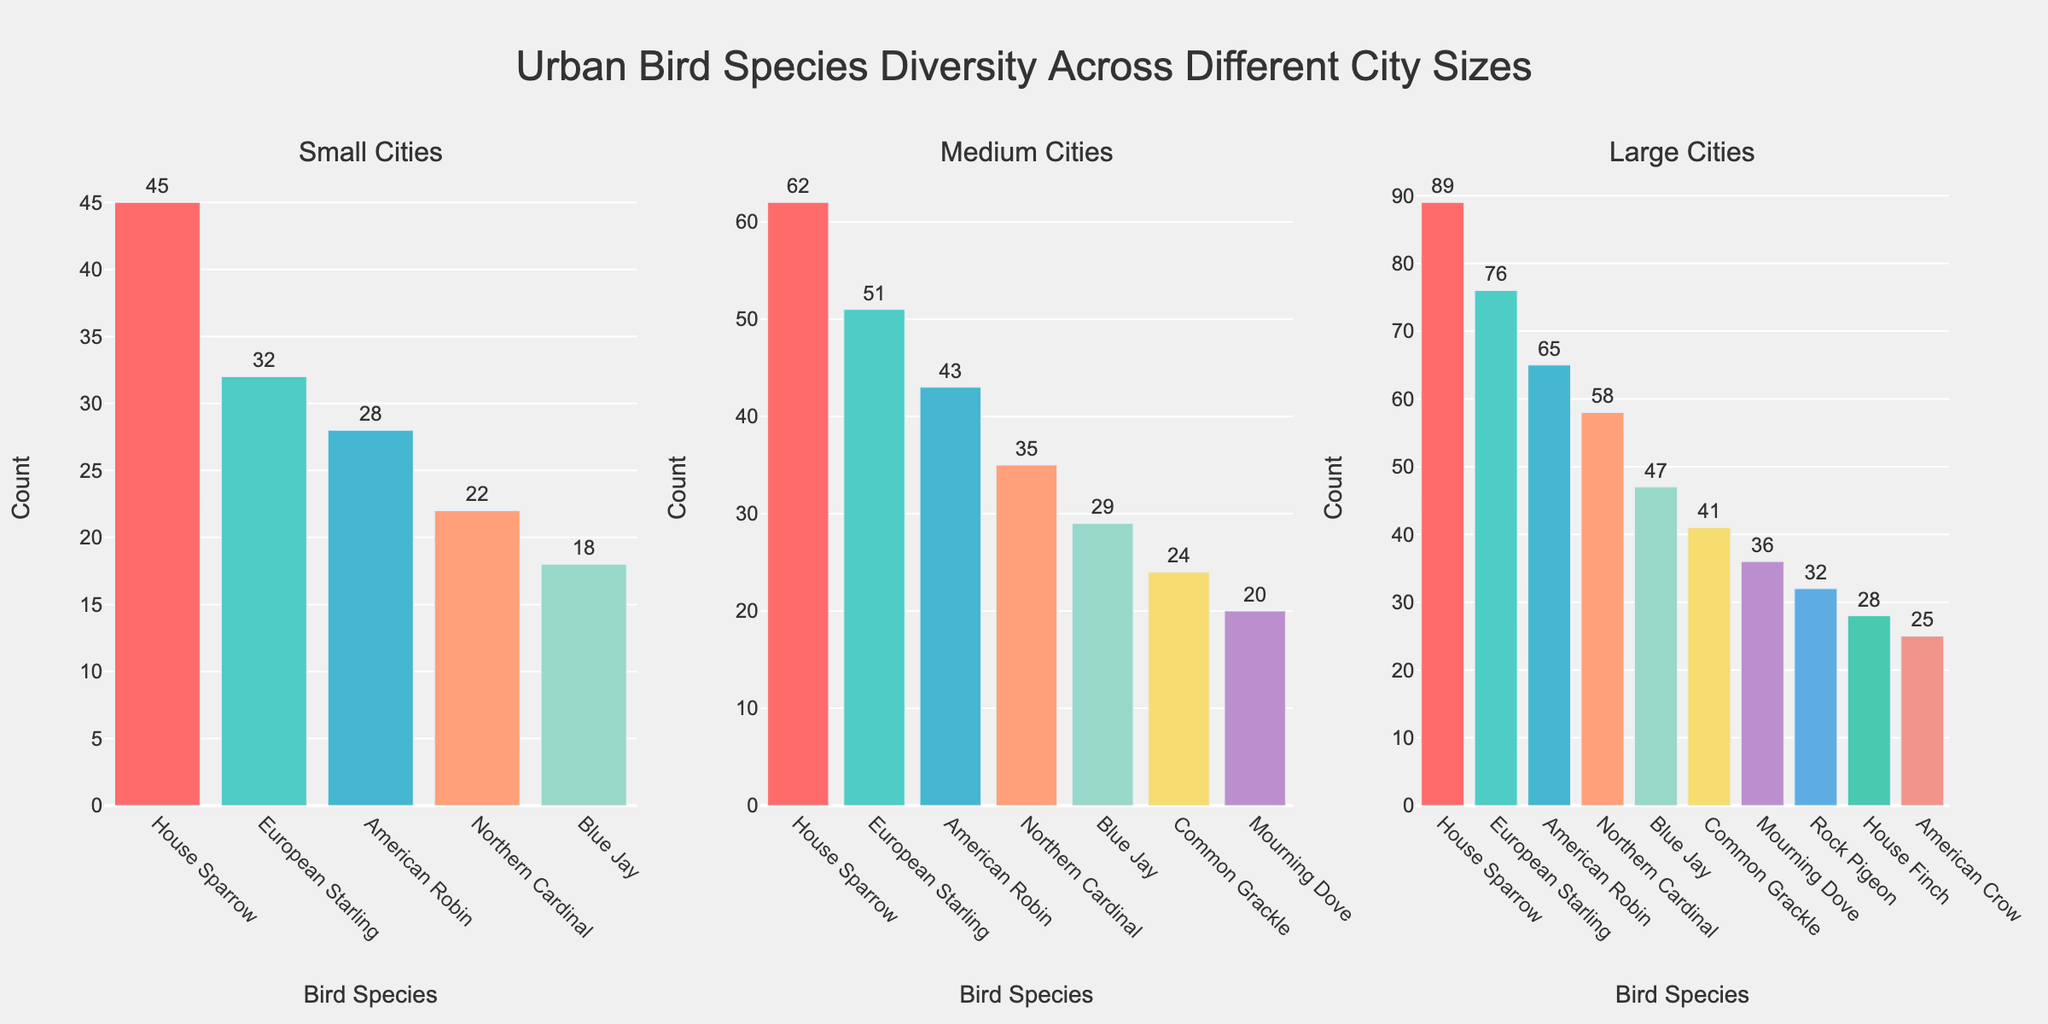How many bird species are represented in small cities? Look at the subplot labeled "Small Cities" and count the unique bird species. There are 5 unique bird species listed for small cities.
Answer: 5 What is the most common bird species in large cities? Check the "Large Cities" subplot and find the bird species with the tallest bar. The House Sparrow has the highest count, indicating it is the most common.
Answer: House Sparrow Which city size has the highest diversity of bird species? Compare the number of unique bird species in all three subplots. Large cities have more unique bird species (10) compared to medium (7) and small cities (5).
Answer: Large cities How many American Robins are there in medium cities? Look at the "Medium Cities" subplot and find the bar labeled "American Robin." The count next to it is 43.
Answer: 43 By how much does the count of European Starlings differ between small and medium cities? Subtract the count of European Starlings in small cities (32) from the count in medium cities (51). 51 - 32 = 19
Answer: 19 What is the combined count of Northern Cardinals across all city sizes? Add the counts of Northern Cardinals from all three subplots. In small cities: 22, in medium cities: 35, in large cities: 58. 22 + 35 + 58 = 115
Answer: 115 Which bird species is exclusive to large cities based on this figure? Identify the species present only in the "Large Cities" subplot but absent in the other two subplots. Rock Pigeon and House Finch appear only in large cities.
Answer: Rock Pigeon, House Finch Is the count of House Sparrows in large cities greater than the combined count of Blue Jays in small and medium cities? Compare the count of House Sparrows in large cities (89) with the sum of Blue Jays in small (18) and medium cities (29). 18 + 29 = 47, and 89 > 47, so the answer is yes.
Answer: Yes How do the counts of Common Grackles compare between medium and large cities? Look at the subplots to find the counts of Common Grackles: 24 in medium cities and 41 in large cities. 41 > 24.
Answer: More in large cities What is the total number of birds counted in small cities? Sum up the counts of all bird species listed in the "Small Cities" subplot. 45 + 32 + 28 + 22 + 18 = 145
Answer: 145 